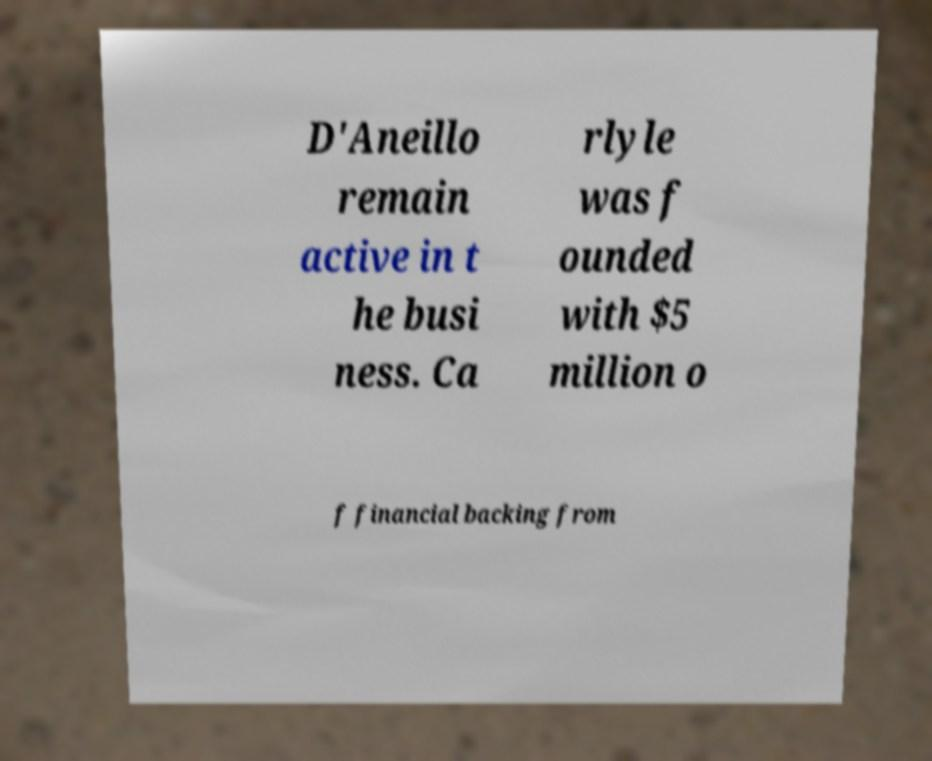What messages or text are displayed in this image? I need them in a readable, typed format. D'Aneillo remain active in t he busi ness. Ca rlyle was f ounded with $5 million o f financial backing from 